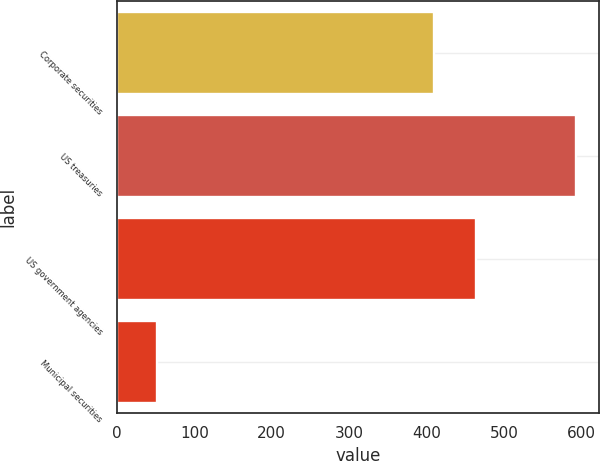Convert chart to OTSL. <chart><loc_0><loc_0><loc_500><loc_500><bar_chart><fcel>Corporate securities<fcel>US treasuries<fcel>US government agencies<fcel>Municipal securities<nl><fcel>409.6<fcel>592.8<fcel>463.71<fcel>51.7<nl></chart> 